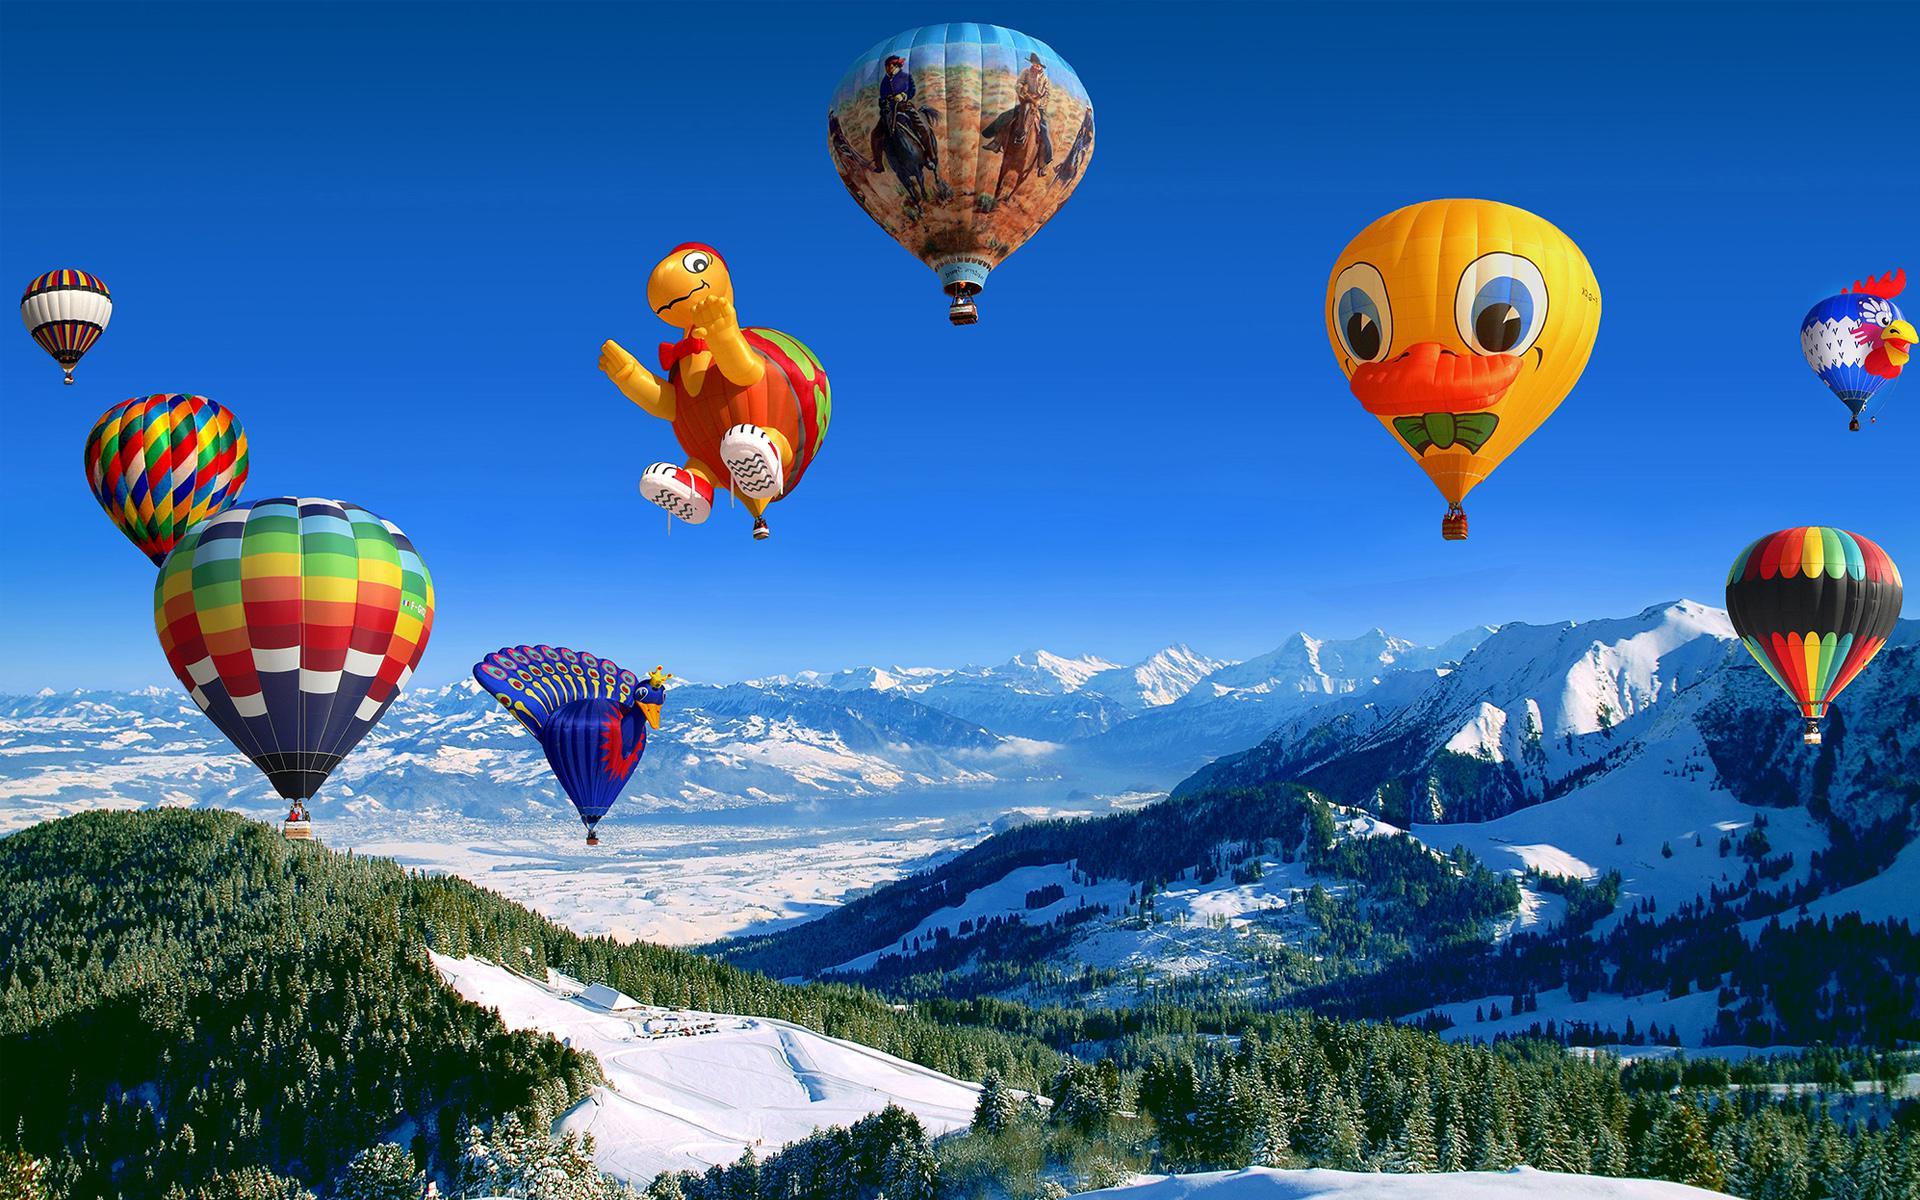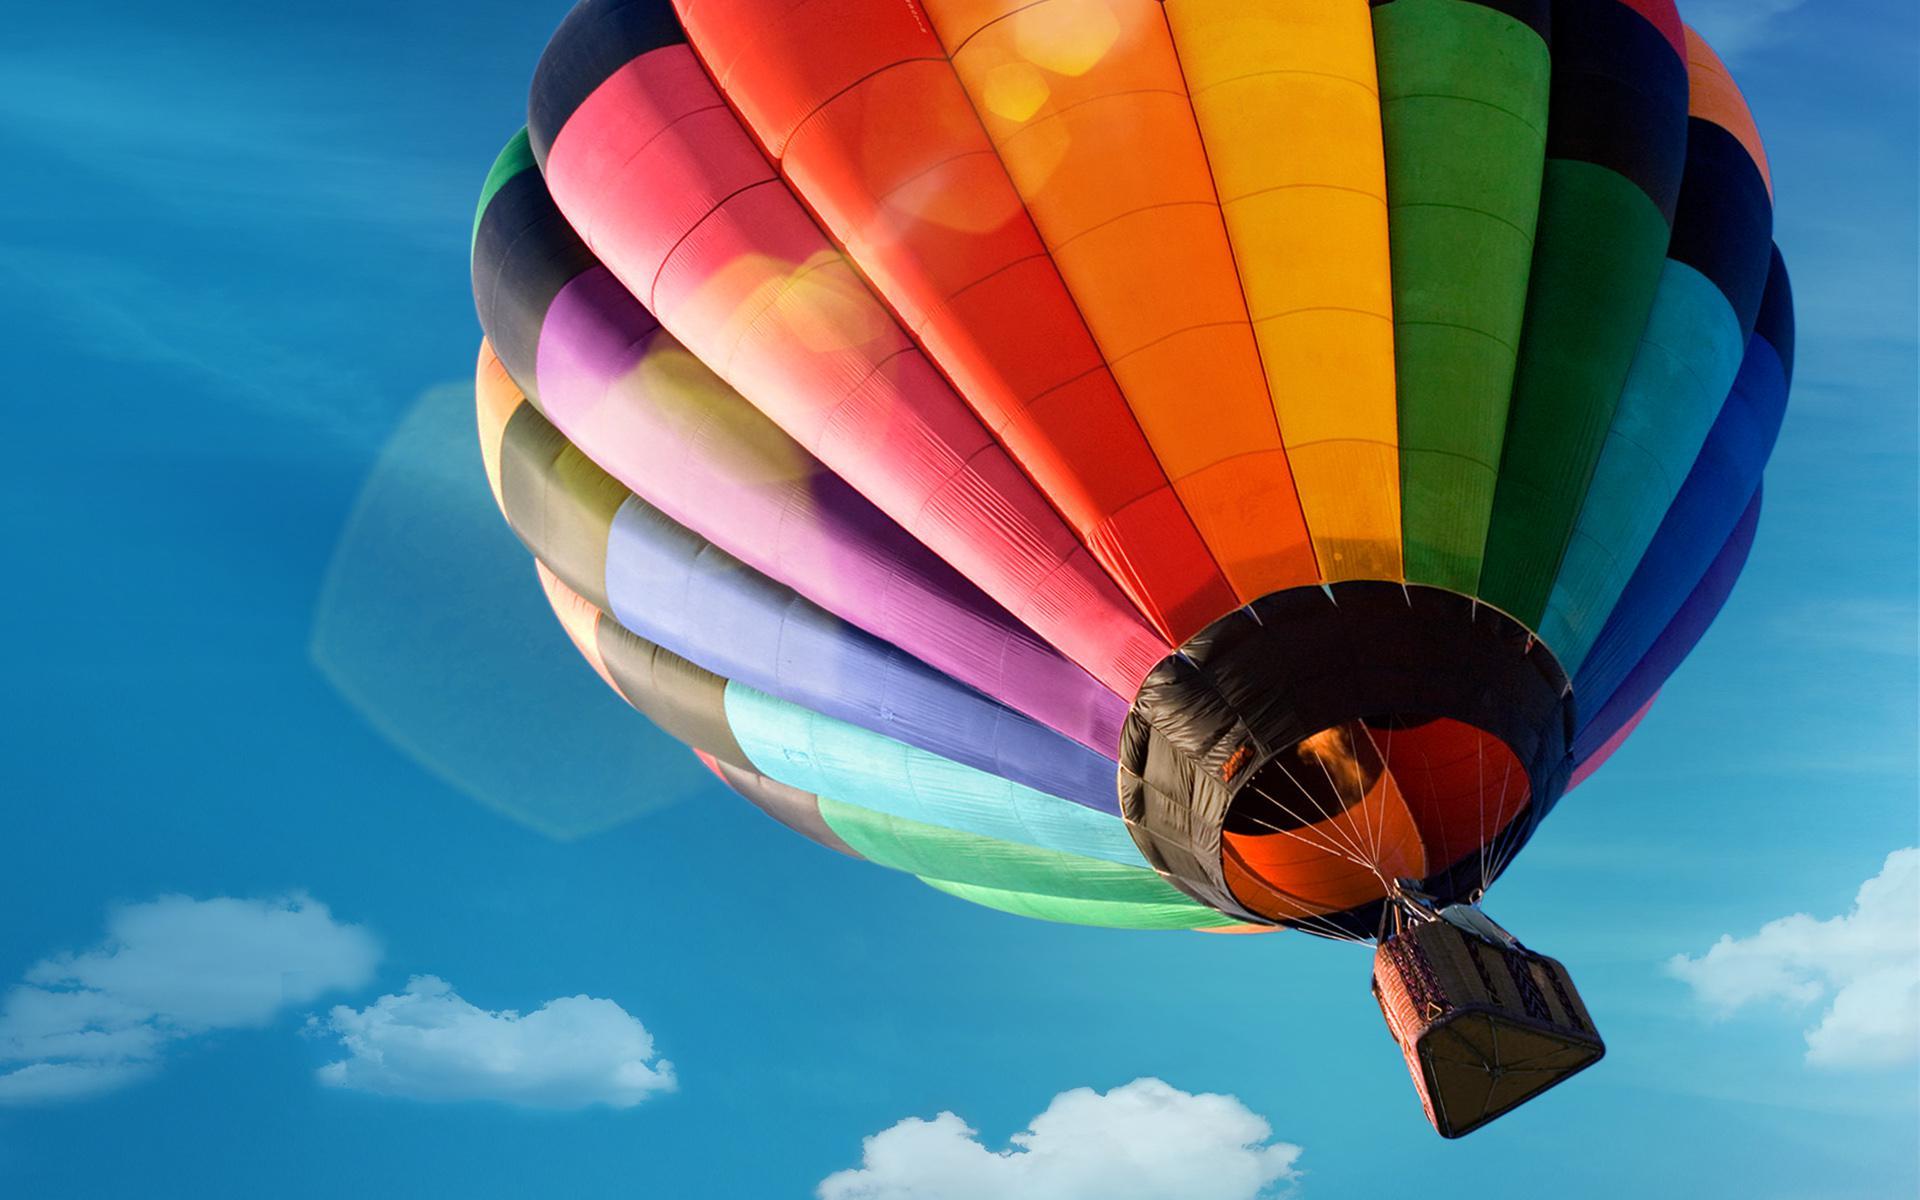The first image is the image on the left, the second image is the image on the right. Considering the images on both sides, is "In one image, a face is designed on the side of a large yellow hot-air balloon." valid? Answer yes or no. Yes. The first image is the image on the left, the second image is the image on the right. Examine the images to the left and right. Is the description "There are at least four balloons in the image on the left." accurate? Answer yes or no. Yes. 